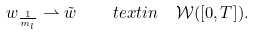<formula> <loc_0><loc_0><loc_500><loc_500>w _ { \frac { 1 } { m _ { l } } } \rightharpoonup \tilde { w } \quad t e x t { i n } \ \ { \mathcal { W } } ( [ 0 , T ] ) .</formula> 